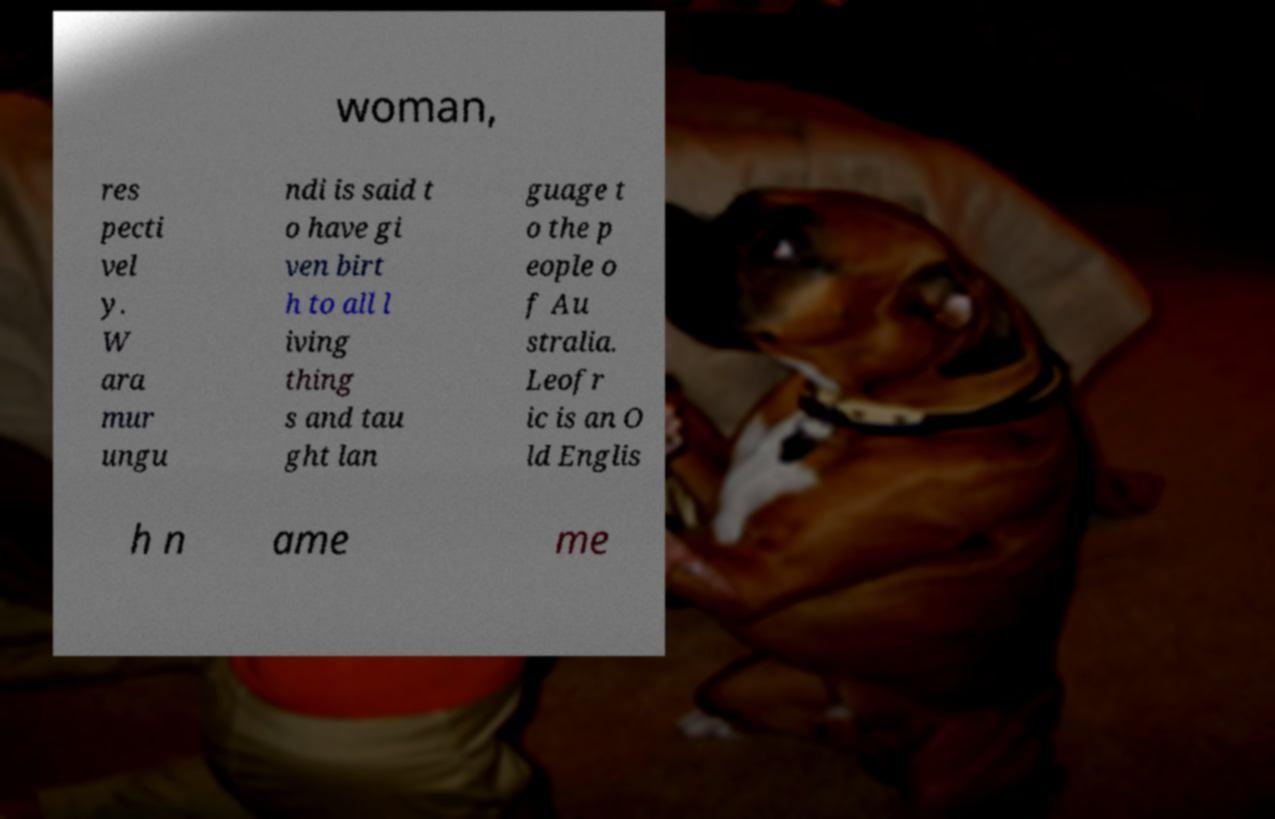Please read and relay the text visible in this image. What does it say? woman, res pecti vel y. W ara mur ungu ndi is said t o have gi ven birt h to all l iving thing s and tau ght lan guage t o the p eople o f Au stralia. Leofr ic is an O ld Englis h n ame me 